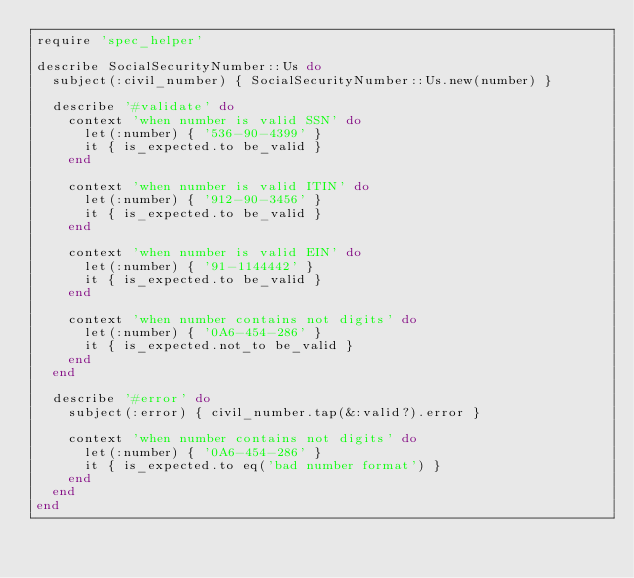<code> <loc_0><loc_0><loc_500><loc_500><_Ruby_>require 'spec_helper'

describe SocialSecurityNumber::Us do
  subject(:civil_number) { SocialSecurityNumber::Us.new(number) }

  describe '#validate' do
    context 'when number is valid SSN' do
      let(:number) { '536-90-4399' }
      it { is_expected.to be_valid }
    end

    context 'when number is valid ITIN' do
      let(:number) { '912-90-3456' }
      it { is_expected.to be_valid }
    end

    context 'when number is valid EIN' do
      let(:number) { '91-1144442' }
      it { is_expected.to be_valid }
    end

    context 'when number contains not digits' do
      let(:number) { '0A6-454-286' }
      it { is_expected.not_to be_valid }
    end
  end

  describe '#error' do
    subject(:error) { civil_number.tap(&:valid?).error }

    context 'when number contains not digits' do
      let(:number) { '0A6-454-286' }
      it { is_expected.to eq('bad number format') }
    end
  end
end
</code> 